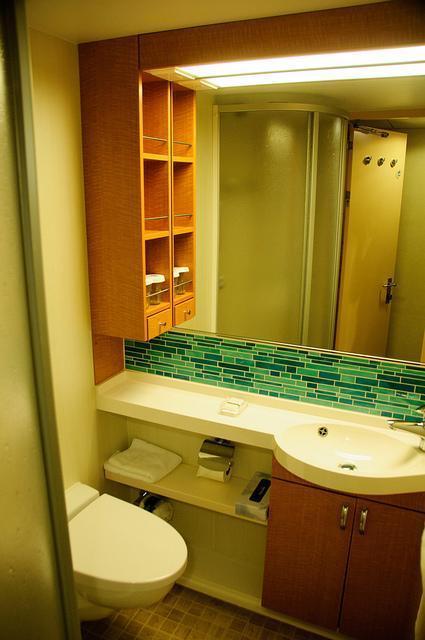How many drawers are in the wall cabinet?
Give a very brief answer. 2. How many toilets are there?
Give a very brief answer. 1. 